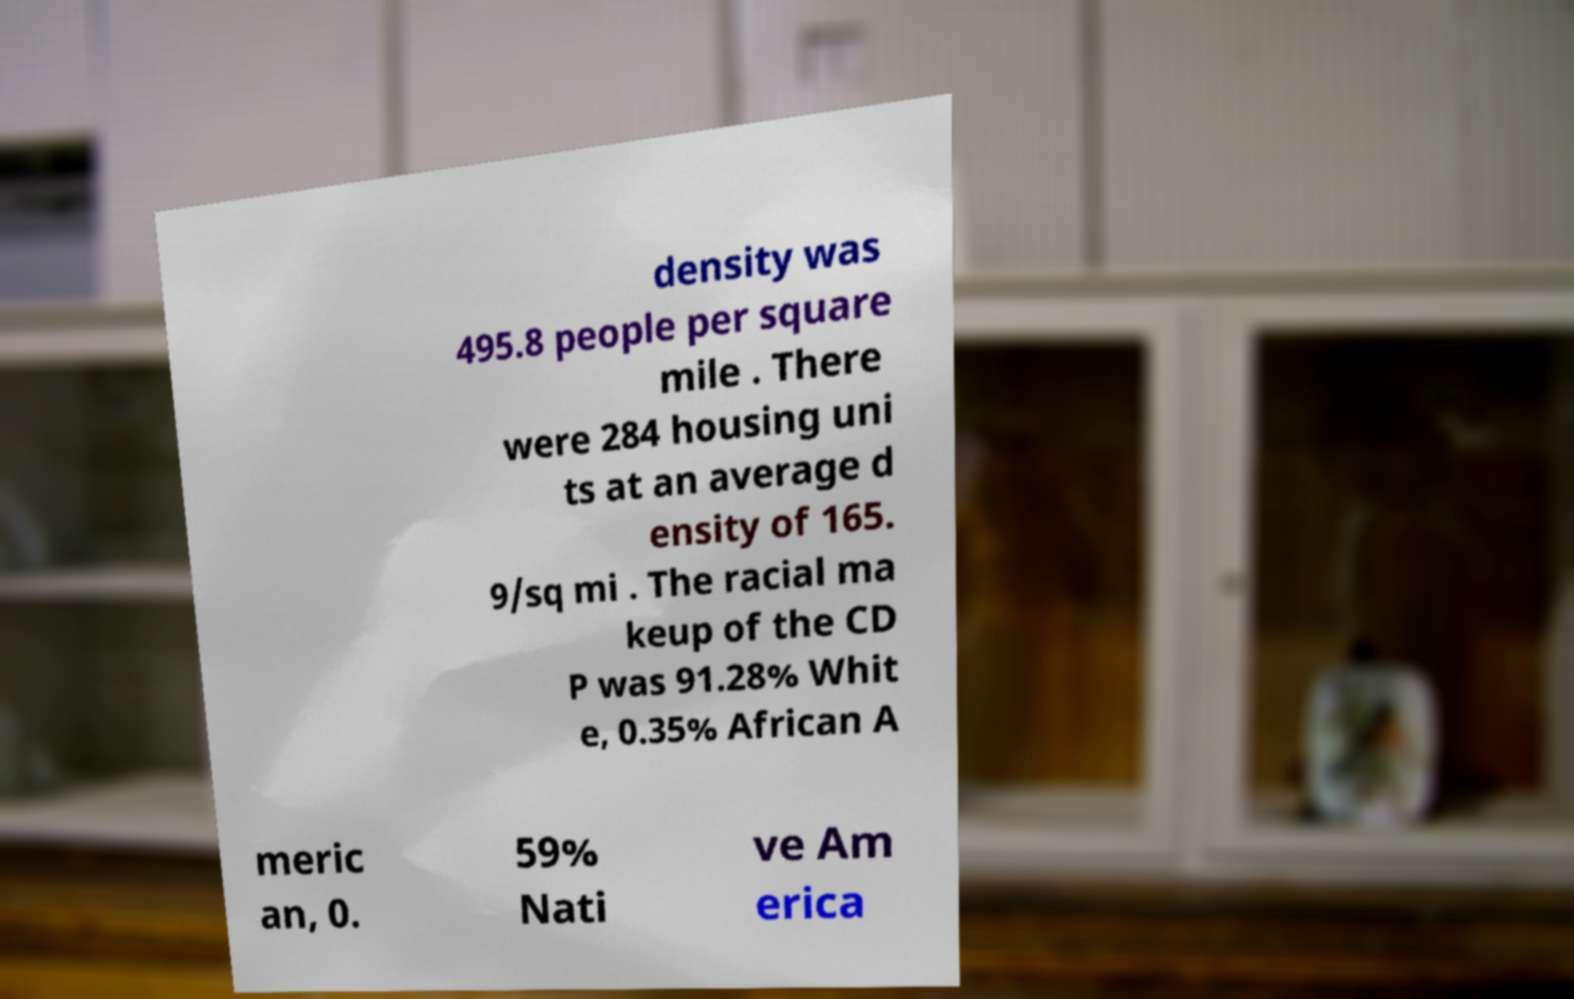Could you assist in decoding the text presented in this image and type it out clearly? density was 495.8 people per square mile . There were 284 housing uni ts at an average d ensity of 165. 9/sq mi . The racial ma keup of the CD P was 91.28% Whit e, 0.35% African A meric an, 0. 59% Nati ve Am erica 